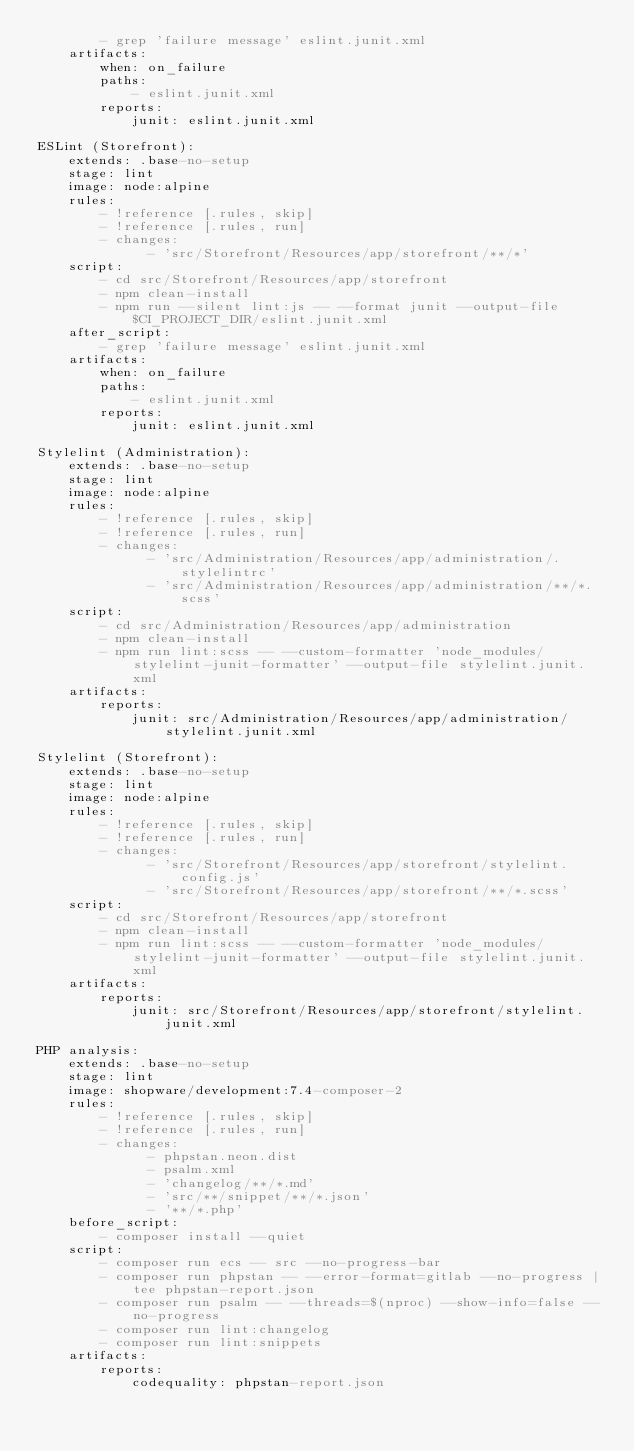<code> <loc_0><loc_0><loc_500><loc_500><_YAML_>        - grep 'failure message' eslint.junit.xml
    artifacts:
        when: on_failure
        paths:
            - eslint.junit.xml
        reports:
            junit: eslint.junit.xml

ESLint (Storefront):
    extends: .base-no-setup
    stage: lint
    image: node:alpine
    rules:
        - !reference [.rules, skip]
        - !reference [.rules, run]
        - changes:
              - 'src/Storefront/Resources/app/storefront/**/*'
    script:
        - cd src/Storefront/Resources/app/storefront
        - npm clean-install
        - npm run --silent lint:js -- --format junit --output-file $CI_PROJECT_DIR/eslint.junit.xml
    after_script:
        - grep 'failure message' eslint.junit.xml
    artifacts:
        when: on_failure
        paths:
            - eslint.junit.xml
        reports:
            junit: eslint.junit.xml

Stylelint (Administration):
    extends: .base-no-setup
    stage: lint
    image: node:alpine
    rules:
        - !reference [.rules, skip]
        - !reference [.rules, run]
        - changes:
              - 'src/Administration/Resources/app/administration/.stylelintrc'
              - 'src/Administration/Resources/app/administration/**/*.scss'
    script:
        - cd src/Administration/Resources/app/administration
        - npm clean-install
        - npm run lint:scss -- --custom-formatter 'node_modules/stylelint-junit-formatter' --output-file stylelint.junit.xml
    artifacts:
        reports:
            junit: src/Administration/Resources/app/administration/stylelint.junit.xml

Stylelint (Storefront):
    extends: .base-no-setup
    stage: lint
    image: node:alpine
    rules:
        - !reference [.rules, skip]
        - !reference [.rules, run]
        - changes:
              - 'src/Storefront/Resources/app/storefront/stylelint.config.js'
              - 'src/Storefront/Resources/app/storefront/**/*.scss'
    script:
        - cd src/Storefront/Resources/app/storefront
        - npm clean-install
        - npm run lint:scss -- --custom-formatter 'node_modules/stylelint-junit-formatter' --output-file stylelint.junit.xml
    artifacts:
        reports:
            junit: src/Storefront/Resources/app/storefront/stylelint.junit.xml

PHP analysis:
    extends: .base-no-setup
    stage: lint
    image: shopware/development:7.4-composer-2
    rules:
        - !reference [.rules, skip]
        - !reference [.rules, run]
        - changes:
              - phpstan.neon.dist
              - psalm.xml
              - 'changelog/**/*.md'
              - 'src/**/snippet/**/*.json'
              - '**/*.php'
    before_script:
        - composer install --quiet
    script:
        - composer run ecs -- src --no-progress-bar
        - composer run phpstan -- --error-format=gitlab --no-progress | tee phpstan-report.json
        - composer run psalm -- --threads=$(nproc) --show-info=false --no-progress
        - composer run lint:changelog
        - composer run lint:snippets
    artifacts:
        reports:
            codequality: phpstan-report.json
</code> 